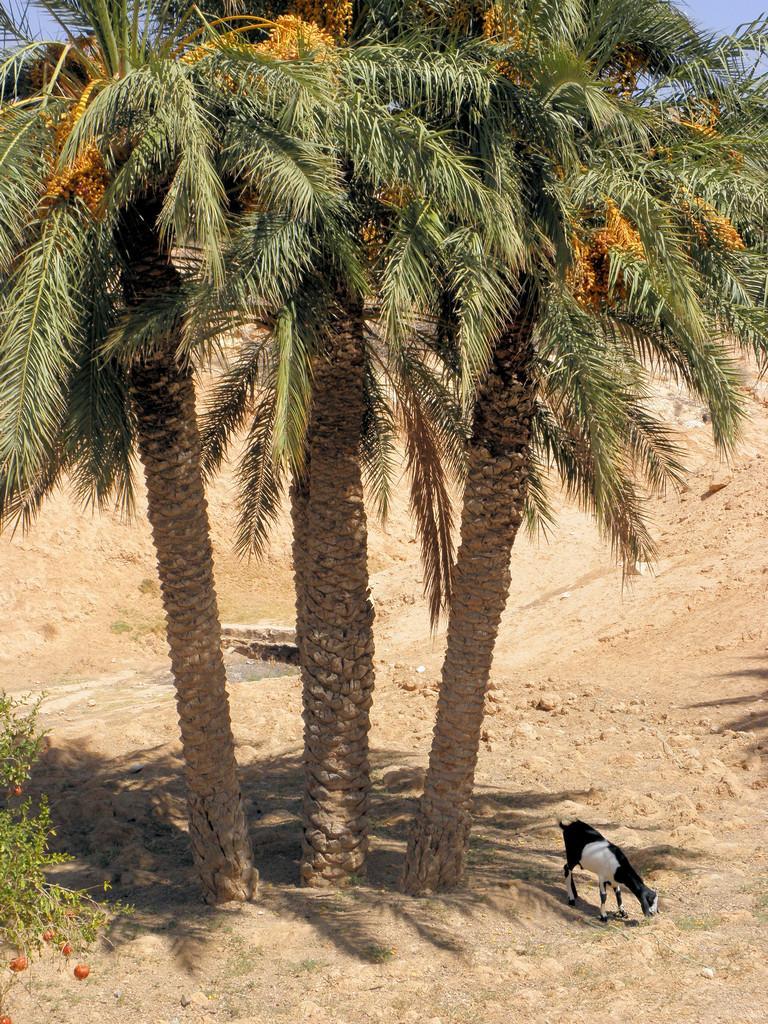In one or two sentences, can you explain what this image depicts? In the foreground of this image, there are trees. On the left, there is a tree. We can also see a goat on the land and at the top, there is the sky. 